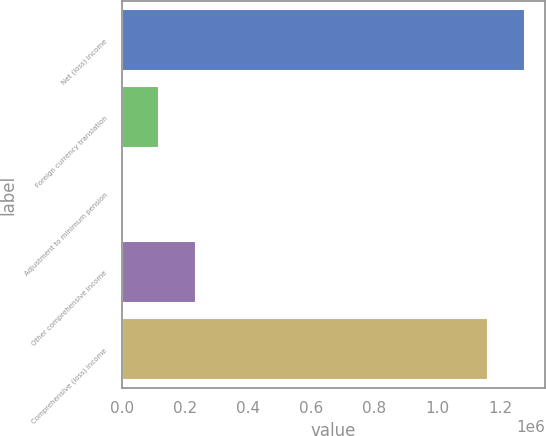Convert chart. <chart><loc_0><loc_0><loc_500><loc_500><bar_chart><fcel>Net (loss) income<fcel>Foreign currency translation<fcel>Adjustment to minimum pension<fcel>Other comprehensive income<fcel>Comprehensive (loss) income<nl><fcel>1.27651e+06<fcel>117404<fcel>134<fcel>234675<fcel>1.15924e+06<nl></chart> 